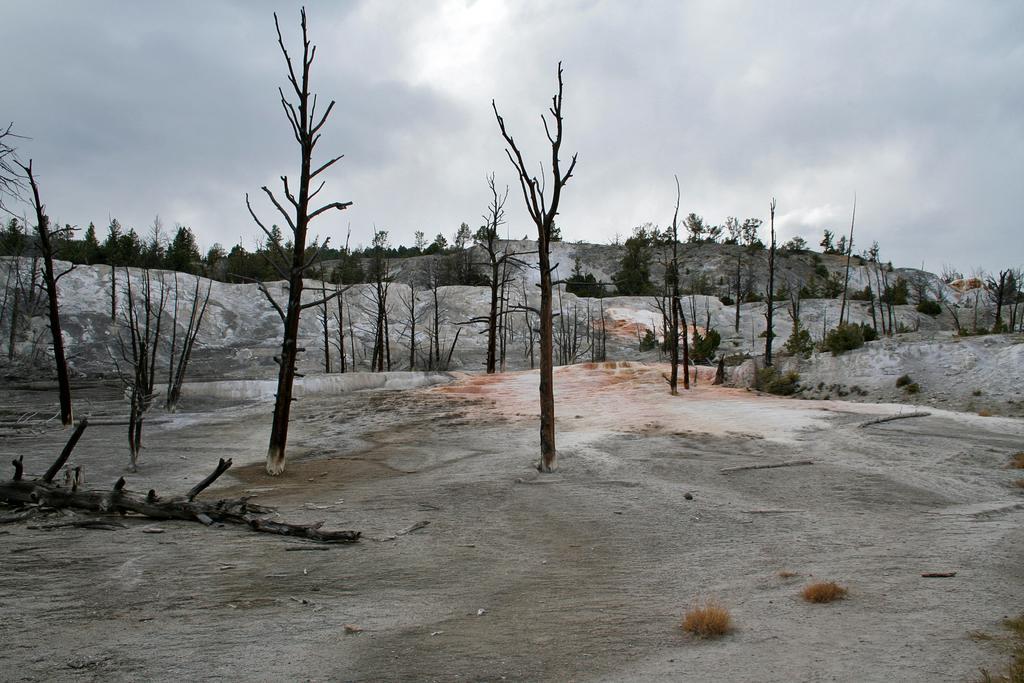Describe this image in one or two sentences. There are dry trees on the dry land. In the background, there are trees on the hills and there are clouds in the sky. 